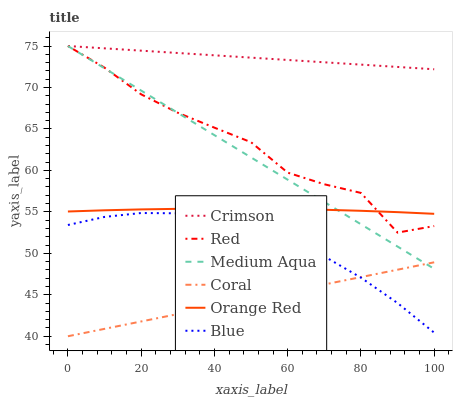Does Coral have the minimum area under the curve?
Answer yes or no. Yes. Does Crimson have the maximum area under the curve?
Answer yes or no. Yes. Does Medium Aqua have the minimum area under the curve?
Answer yes or no. No. Does Medium Aqua have the maximum area under the curve?
Answer yes or no. No. Is Coral the smoothest?
Answer yes or no. Yes. Is Red the roughest?
Answer yes or no. Yes. Is Medium Aqua the smoothest?
Answer yes or no. No. Is Medium Aqua the roughest?
Answer yes or no. No. Does Coral have the lowest value?
Answer yes or no. Yes. Does Medium Aqua have the lowest value?
Answer yes or no. No. Does Red have the highest value?
Answer yes or no. Yes. Does Coral have the highest value?
Answer yes or no. No. Is Blue less than Medium Aqua?
Answer yes or no. Yes. Is Orange Red greater than Coral?
Answer yes or no. Yes. Does Orange Red intersect Medium Aqua?
Answer yes or no. Yes. Is Orange Red less than Medium Aqua?
Answer yes or no. No. Is Orange Red greater than Medium Aqua?
Answer yes or no. No. Does Blue intersect Medium Aqua?
Answer yes or no. No. 